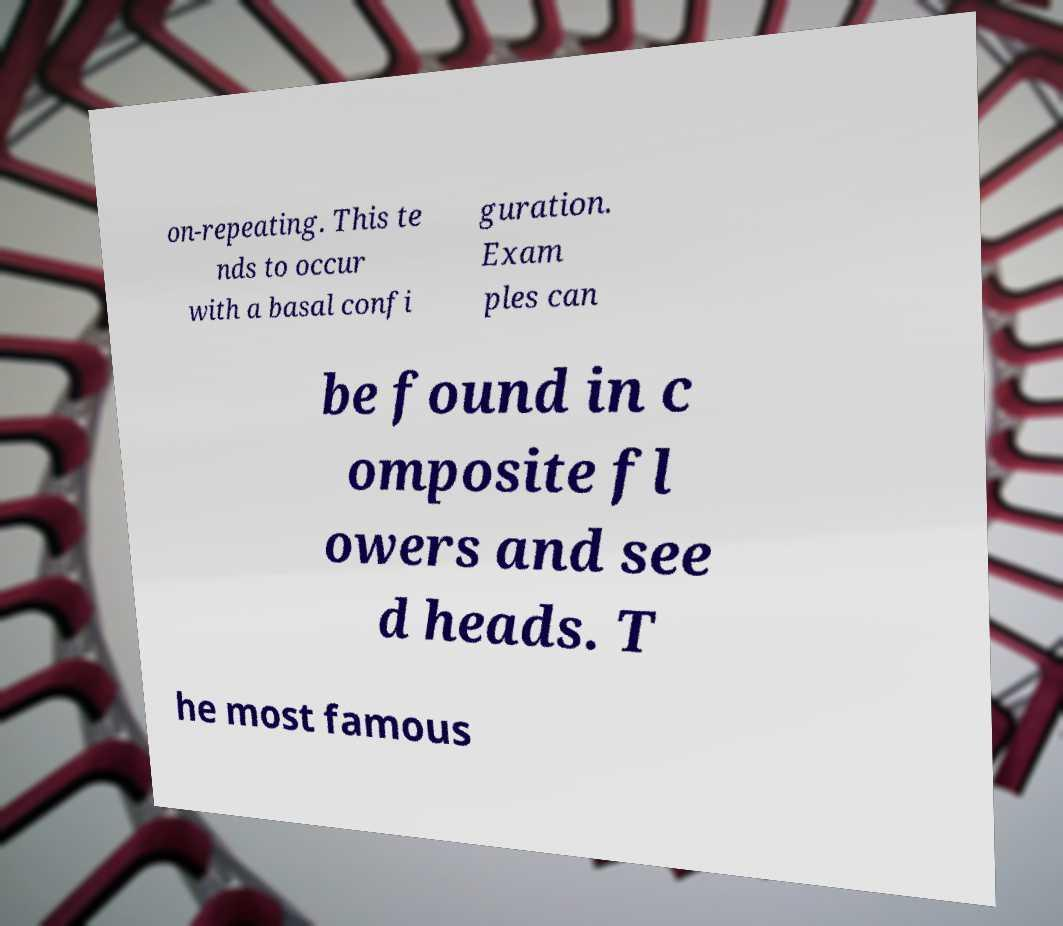Could you assist in decoding the text presented in this image and type it out clearly? on-repeating. This te nds to occur with a basal confi guration. Exam ples can be found in c omposite fl owers and see d heads. T he most famous 